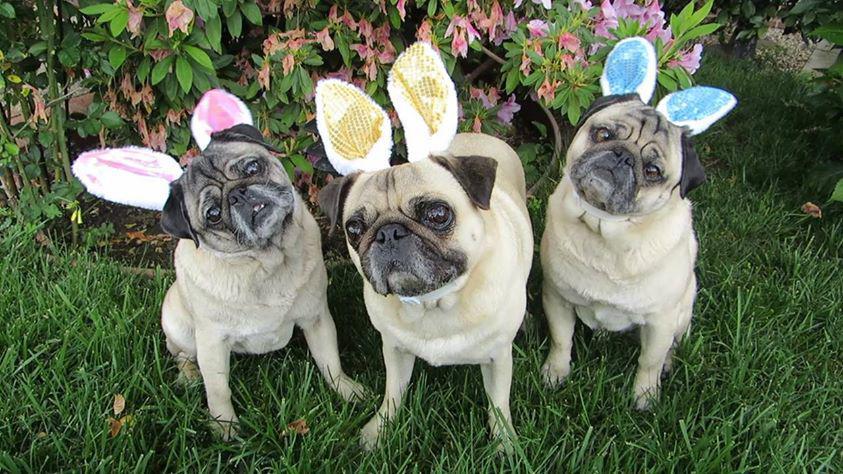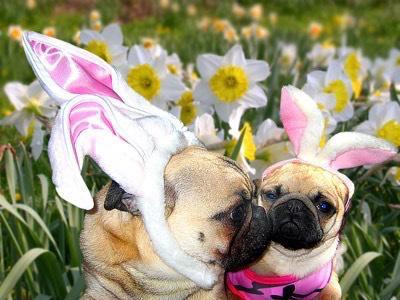The first image is the image on the left, the second image is the image on the right. For the images displayed, is the sentence "The left image shows a pug wearing bunny ears by a stuffed toy with bunny ears." factually correct? Answer yes or no. No. The first image is the image on the left, the second image is the image on the right. For the images displayed, is the sentence "there is a pug  wearing costume bunny ears laying next to a stuffed bunny toy" factually correct? Answer yes or no. No. 